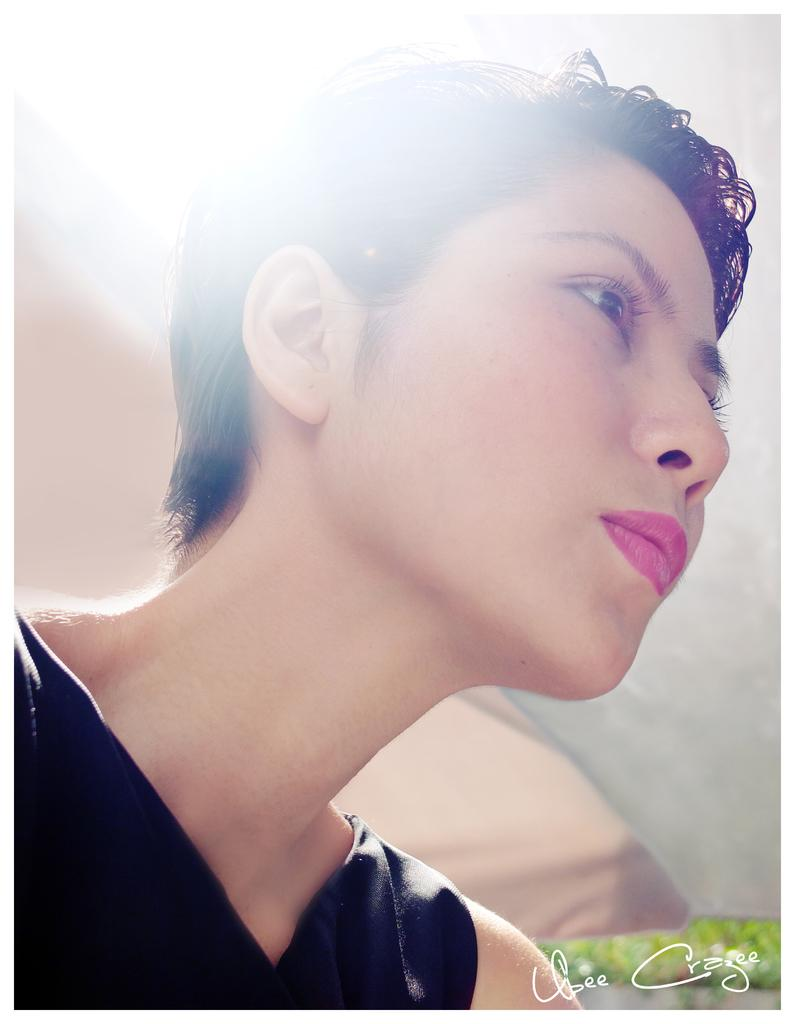Who is the main subject in the image? There is a woman in the image. What is the woman wearing? The woman is wearing a black dress. Is there any text or marking in the image? Yes, there is a watermark in the bottom right side of the image. What trail does the woman follow in the image? There is no trail visible in the image, and the woman is not shown following any path. 